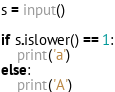Convert code to text. <code><loc_0><loc_0><loc_500><loc_500><_Python_>s = input()

if s.islower() == 1:
    print('a')
else:
    print('A')</code> 